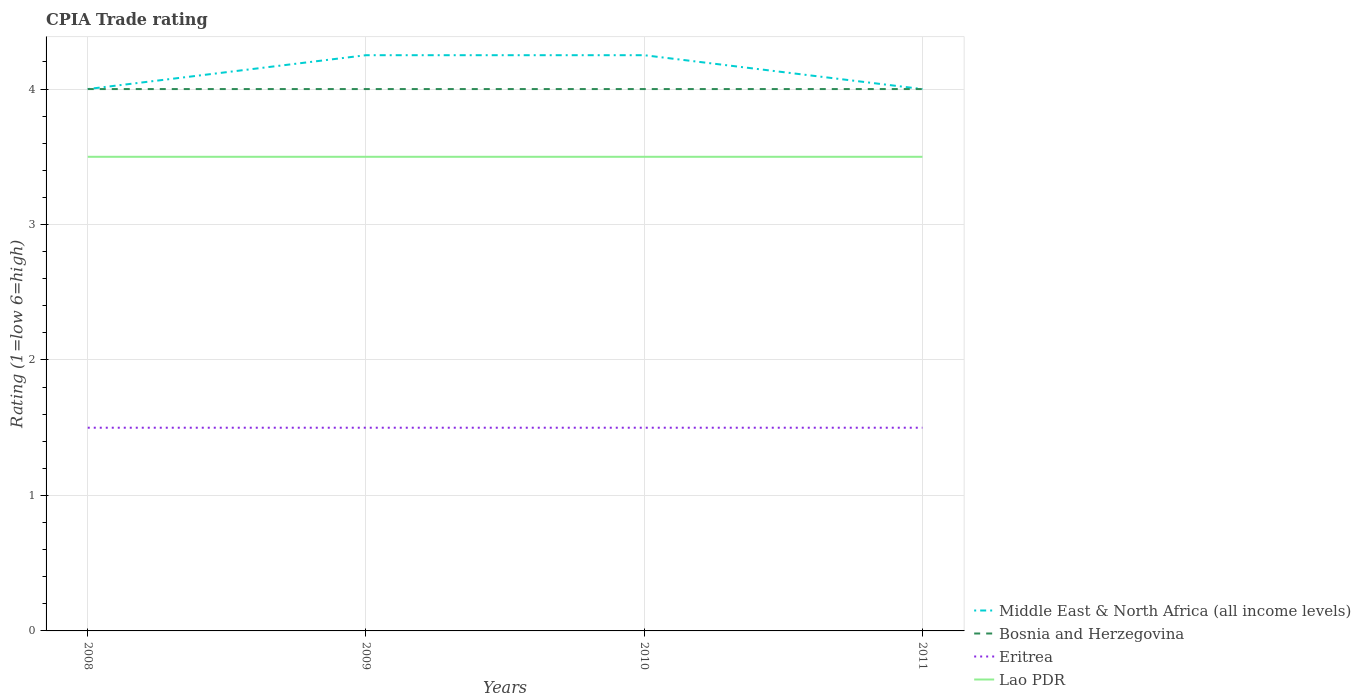Does the line corresponding to Lao PDR intersect with the line corresponding to Bosnia and Herzegovina?
Your answer should be compact. No. Across all years, what is the maximum CPIA rating in Bosnia and Herzegovina?
Provide a succinct answer. 4. What is the total CPIA rating in Eritrea in the graph?
Give a very brief answer. 0. What is the difference between the highest and the second highest CPIA rating in Middle East & North Africa (all income levels)?
Keep it short and to the point. 0.25. How many lines are there?
Give a very brief answer. 4. Are the values on the major ticks of Y-axis written in scientific E-notation?
Your answer should be compact. No. How many legend labels are there?
Keep it short and to the point. 4. How are the legend labels stacked?
Provide a succinct answer. Vertical. What is the title of the graph?
Offer a very short reply. CPIA Trade rating. What is the label or title of the Y-axis?
Your answer should be very brief. Rating (1=low 6=high). What is the Rating (1=low 6=high) of Middle East & North Africa (all income levels) in 2008?
Make the answer very short. 4. What is the Rating (1=low 6=high) of Bosnia and Herzegovina in 2008?
Provide a short and direct response. 4. What is the Rating (1=low 6=high) in Middle East & North Africa (all income levels) in 2009?
Offer a terse response. 4.25. What is the Rating (1=low 6=high) of Eritrea in 2009?
Offer a terse response. 1.5. What is the Rating (1=low 6=high) of Middle East & North Africa (all income levels) in 2010?
Your response must be concise. 4.25. What is the Rating (1=low 6=high) of Eritrea in 2010?
Provide a short and direct response. 1.5. What is the Rating (1=low 6=high) in Middle East & North Africa (all income levels) in 2011?
Keep it short and to the point. 4. Across all years, what is the maximum Rating (1=low 6=high) in Middle East & North Africa (all income levels)?
Keep it short and to the point. 4.25. Across all years, what is the maximum Rating (1=low 6=high) in Bosnia and Herzegovina?
Your response must be concise. 4. Across all years, what is the maximum Rating (1=low 6=high) in Eritrea?
Provide a short and direct response. 1.5. Across all years, what is the maximum Rating (1=low 6=high) of Lao PDR?
Give a very brief answer. 3.5. Across all years, what is the minimum Rating (1=low 6=high) of Bosnia and Herzegovina?
Give a very brief answer. 4. Across all years, what is the minimum Rating (1=low 6=high) of Eritrea?
Your answer should be compact. 1.5. Across all years, what is the minimum Rating (1=low 6=high) of Lao PDR?
Offer a very short reply. 3.5. What is the total Rating (1=low 6=high) in Middle East & North Africa (all income levels) in the graph?
Your answer should be compact. 16.5. What is the total Rating (1=low 6=high) in Eritrea in the graph?
Offer a terse response. 6. What is the total Rating (1=low 6=high) of Lao PDR in the graph?
Your answer should be very brief. 14. What is the difference between the Rating (1=low 6=high) in Eritrea in 2008 and that in 2009?
Provide a short and direct response. 0. What is the difference between the Rating (1=low 6=high) in Lao PDR in 2008 and that in 2009?
Your response must be concise. 0. What is the difference between the Rating (1=low 6=high) of Bosnia and Herzegovina in 2008 and that in 2010?
Offer a terse response. 0. What is the difference between the Rating (1=low 6=high) in Lao PDR in 2008 and that in 2010?
Ensure brevity in your answer.  0. What is the difference between the Rating (1=low 6=high) in Middle East & North Africa (all income levels) in 2008 and that in 2011?
Your answer should be compact. 0. What is the difference between the Rating (1=low 6=high) of Eritrea in 2008 and that in 2011?
Your answer should be very brief. 0. What is the difference between the Rating (1=low 6=high) of Lao PDR in 2008 and that in 2011?
Your response must be concise. 0. What is the difference between the Rating (1=low 6=high) in Bosnia and Herzegovina in 2009 and that in 2011?
Your answer should be very brief. 0. What is the difference between the Rating (1=low 6=high) in Lao PDR in 2009 and that in 2011?
Keep it short and to the point. 0. What is the difference between the Rating (1=low 6=high) of Middle East & North Africa (all income levels) in 2010 and that in 2011?
Keep it short and to the point. 0.25. What is the difference between the Rating (1=low 6=high) in Eritrea in 2010 and that in 2011?
Give a very brief answer. 0. What is the difference between the Rating (1=low 6=high) in Middle East & North Africa (all income levels) in 2008 and the Rating (1=low 6=high) in Bosnia and Herzegovina in 2009?
Your response must be concise. 0. What is the difference between the Rating (1=low 6=high) in Bosnia and Herzegovina in 2008 and the Rating (1=low 6=high) in Lao PDR in 2009?
Your answer should be compact. 0.5. What is the difference between the Rating (1=low 6=high) in Eritrea in 2008 and the Rating (1=low 6=high) in Lao PDR in 2009?
Keep it short and to the point. -2. What is the difference between the Rating (1=low 6=high) of Bosnia and Herzegovina in 2008 and the Rating (1=low 6=high) of Eritrea in 2010?
Keep it short and to the point. 2.5. What is the difference between the Rating (1=low 6=high) in Bosnia and Herzegovina in 2008 and the Rating (1=low 6=high) in Lao PDR in 2010?
Give a very brief answer. 0.5. What is the difference between the Rating (1=low 6=high) in Middle East & North Africa (all income levels) in 2008 and the Rating (1=low 6=high) in Bosnia and Herzegovina in 2011?
Provide a short and direct response. 0. What is the difference between the Rating (1=low 6=high) in Middle East & North Africa (all income levels) in 2008 and the Rating (1=low 6=high) in Lao PDR in 2011?
Offer a very short reply. 0.5. What is the difference between the Rating (1=low 6=high) of Middle East & North Africa (all income levels) in 2009 and the Rating (1=low 6=high) of Bosnia and Herzegovina in 2010?
Provide a short and direct response. 0.25. What is the difference between the Rating (1=low 6=high) of Middle East & North Africa (all income levels) in 2009 and the Rating (1=low 6=high) of Eritrea in 2010?
Keep it short and to the point. 2.75. What is the difference between the Rating (1=low 6=high) in Middle East & North Africa (all income levels) in 2009 and the Rating (1=low 6=high) in Lao PDR in 2010?
Your answer should be compact. 0.75. What is the difference between the Rating (1=low 6=high) of Bosnia and Herzegovina in 2009 and the Rating (1=low 6=high) of Lao PDR in 2010?
Make the answer very short. 0.5. What is the difference between the Rating (1=low 6=high) in Eritrea in 2009 and the Rating (1=low 6=high) in Lao PDR in 2010?
Your answer should be very brief. -2. What is the difference between the Rating (1=low 6=high) of Middle East & North Africa (all income levels) in 2009 and the Rating (1=low 6=high) of Bosnia and Herzegovina in 2011?
Provide a short and direct response. 0.25. What is the difference between the Rating (1=low 6=high) in Middle East & North Africa (all income levels) in 2009 and the Rating (1=low 6=high) in Eritrea in 2011?
Make the answer very short. 2.75. What is the difference between the Rating (1=low 6=high) of Bosnia and Herzegovina in 2009 and the Rating (1=low 6=high) of Eritrea in 2011?
Give a very brief answer. 2.5. What is the difference between the Rating (1=low 6=high) of Bosnia and Herzegovina in 2009 and the Rating (1=low 6=high) of Lao PDR in 2011?
Offer a very short reply. 0.5. What is the difference between the Rating (1=low 6=high) of Eritrea in 2009 and the Rating (1=low 6=high) of Lao PDR in 2011?
Your answer should be compact. -2. What is the difference between the Rating (1=low 6=high) of Middle East & North Africa (all income levels) in 2010 and the Rating (1=low 6=high) of Eritrea in 2011?
Offer a terse response. 2.75. What is the difference between the Rating (1=low 6=high) of Middle East & North Africa (all income levels) in 2010 and the Rating (1=low 6=high) of Lao PDR in 2011?
Provide a succinct answer. 0.75. What is the difference between the Rating (1=low 6=high) of Bosnia and Herzegovina in 2010 and the Rating (1=low 6=high) of Eritrea in 2011?
Your response must be concise. 2.5. What is the difference between the Rating (1=low 6=high) in Bosnia and Herzegovina in 2010 and the Rating (1=low 6=high) in Lao PDR in 2011?
Offer a terse response. 0.5. What is the average Rating (1=low 6=high) of Middle East & North Africa (all income levels) per year?
Provide a short and direct response. 4.12. What is the average Rating (1=low 6=high) in Eritrea per year?
Your response must be concise. 1.5. What is the average Rating (1=low 6=high) of Lao PDR per year?
Your response must be concise. 3.5. In the year 2008, what is the difference between the Rating (1=low 6=high) of Bosnia and Herzegovina and Rating (1=low 6=high) of Eritrea?
Your answer should be very brief. 2.5. In the year 2008, what is the difference between the Rating (1=low 6=high) in Bosnia and Herzegovina and Rating (1=low 6=high) in Lao PDR?
Your response must be concise. 0.5. In the year 2008, what is the difference between the Rating (1=low 6=high) of Eritrea and Rating (1=low 6=high) of Lao PDR?
Your answer should be very brief. -2. In the year 2009, what is the difference between the Rating (1=low 6=high) of Middle East & North Africa (all income levels) and Rating (1=low 6=high) of Bosnia and Herzegovina?
Your answer should be compact. 0.25. In the year 2009, what is the difference between the Rating (1=low 6=high) in Middle East & North Africa (all income levels) and Rating (1=low 6=high) in Eritrea?
Offer a terse response. 2.75. In the year 2009, what is the difference between the Rating (1=low 6=high) of Middle East & North Africa (all income levels) and Rating (1=low 6=high) of Lao PDR?
Keep it short and to the point. 0.75. In the year 2009, what is the difference between the Rating (1=low 6=high) in Eritrea and Rating (1=low 6=high) in Lao PDR?
Provide a succinct answer. -2. In the year 2010, what is the difference between the Rating (1=low 6=high) of Middle East & North Africa (all income levels) and Rating (1=low 6=high) of Eritrea?
Provide a short and direct response. 2.75. In the year 2011, what is the difference between the Rating (1=low 6=high) in Middle East & North Africa (all income levels) and Rating (1=low 6=high) in Eritrea?
Keep it short and to the point. 2.5. In the year 2011, what is the difference between the Rating (1=low 6=high) in Bosnia and Herzegovina and Rating (1=low 6=high) in Eritrea?
Offer a terse response. 2.5. In the year 2011, what is the difference between the Rating (1=low 6=high) of Eritrea and Rating (1=low 6=high) of Lao PDR?
Keep it short and to the point. -2. What is the ratio of the Rating (1=low 6=high) of Bosnia and Herzegovina in 2008 to that in 2010?
Offer a very short reply. 1. What is the ratio of the Rating (1=low 6=high) in Middle East & North Africa (all income levels) in 2008 to that in 2011?
Give a very brief answer. 1. What is the ratio of the Rating (1=low 6=high) in Eritrea in 2008 to that in 2011?
Your answer should be compact. 1. What is the ratio of the Rating (1=low 6=high) of Bosnia and Herzegovina in 2009 to that in 2010?
Keep it short and to the point. 1. What is the ratio of the Rating (1=low 6=high) in Eritrea in 2009 to that in 2010?
Your response must be concise. 1. What is the ratio of the Rating (1=low 6=high) of Lao PDR in 2009 to that in 2011?
Your answer should be compact. 1. What is the ratio of the Rating (1=low 6=high) of Middle East & North Africa (all income levels) in 2010 to that in 2011?
Make the answer very short. 1.06. What is the ratio of the Rating (1=low 6=high) in Bosnia and Herzegovina in 2010 to that in 2011?
Provide a succinct answer. 1. What is the difference between the highest and the second highest Rating (1=low 6=high) of Middle East & North Africa (all income levels)?
Offer a terse response. 0. What is the difference between the highest and the second highest Rating (1=low 6=high) in Lao PDR?
Make the answer very short. 0. What is the difference between the highest and the lowest Rating (1=low 6=high) of Middle East & North Africa (all income levels)?
Provide a short and direct response. 0.25. What is the difference between the highest and the lowest Rating (1=low 6=high) of Bosnia and Herzegovina?
Your answer should be compact. 0. 